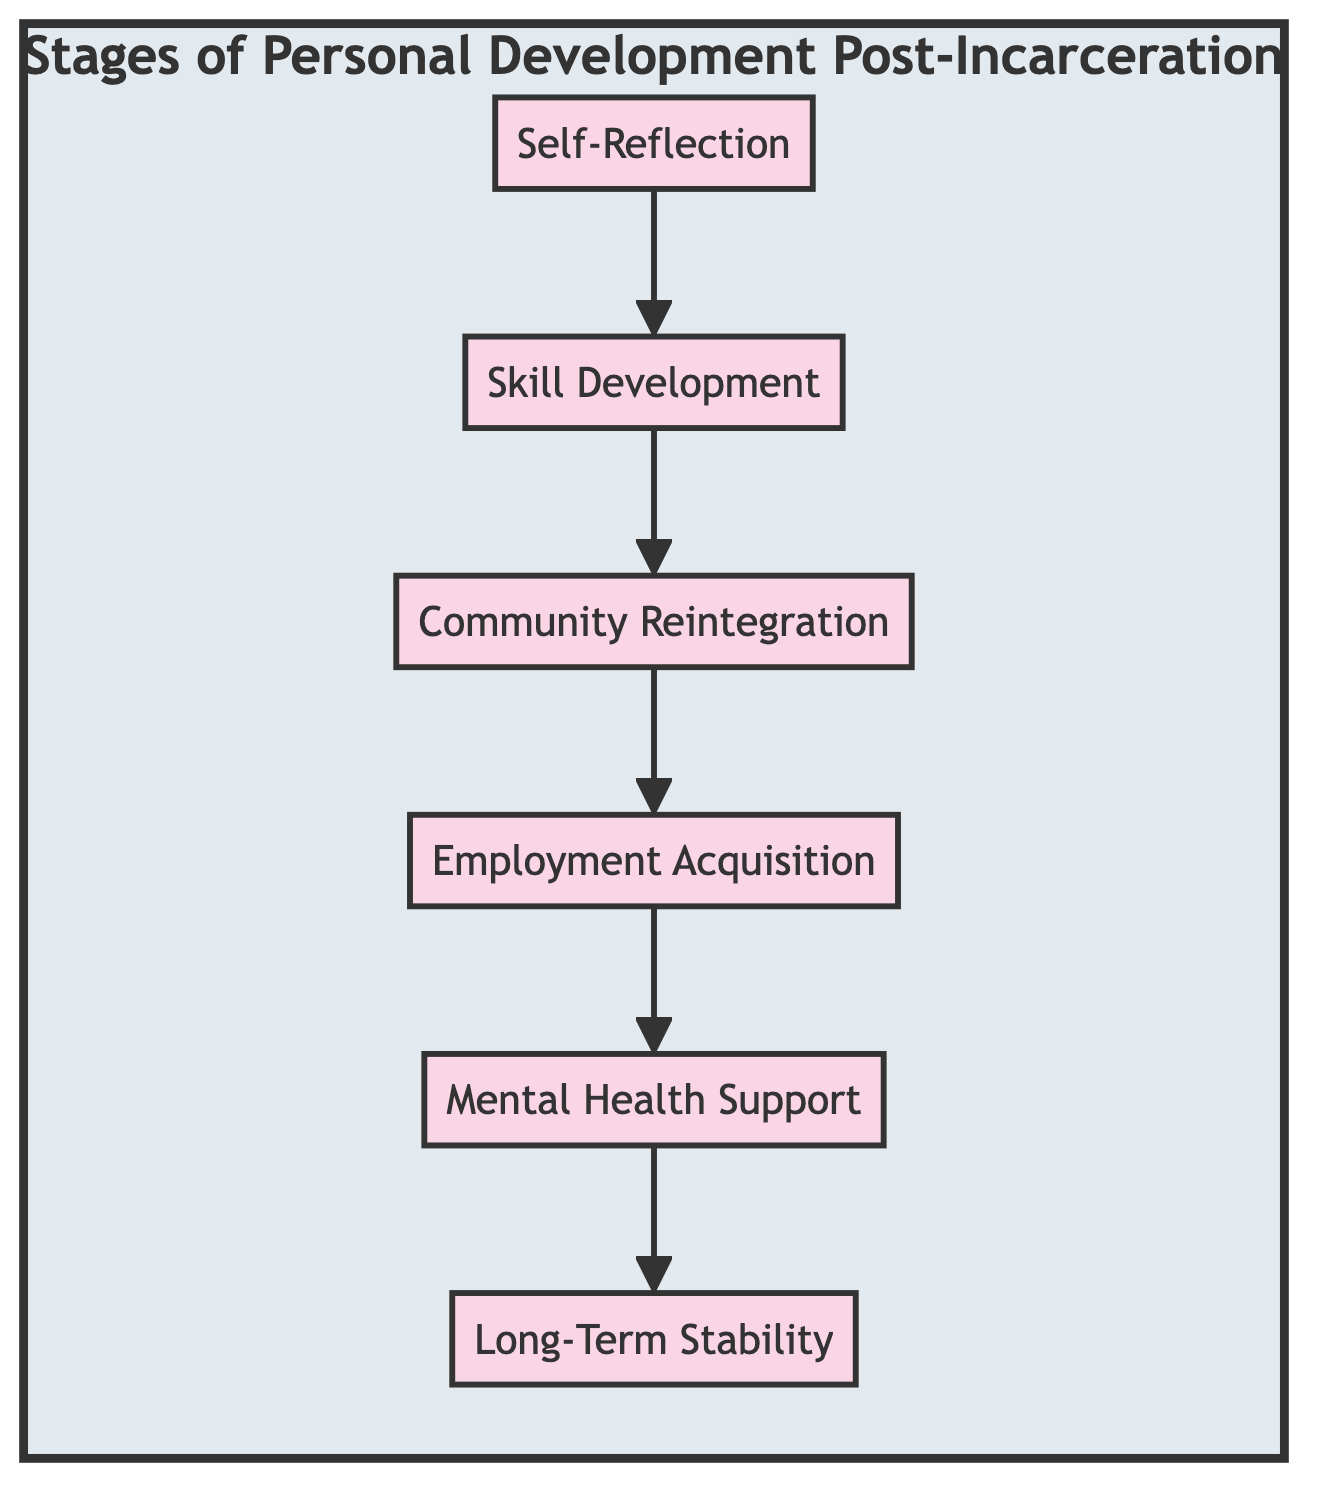What is the first stage of personal development post-incarceration? The diagram indicates that the first stage is labeled "Self-Reflection," shown at the top of the flowchart.
Answer: Self-Reflection How many stages are included in the diagram? By counting the nodes in the diagram, six distinct stages are identified from Self-Reflection to Long-Term Stability.
Answer: 6 What stage directly follows "Skill Development"? The flowchart shows that "Community Reintegration" is the stage connected directly after "Skill Development," indicating its sequence in the process.
Answer: Community Reintegration In which stage is mental health addressed? The diagram links "Mental Health Support" after "Employment Acquisition," indicating this stage focuses on mental health services.
Answer: Mental Health Support Which stage is last in the flow of development? The flowchart concludes with "Long-Term Stability," marking it as the final stage in the process of personal development post-incarceration.
Answer: Long-Term Stability What is the relationship between "Self-Reflection" and "Skill Development"? "Skill Development" follows directly after "Self-Reflection," indicating a sequential process where one stage influences the next.
Answer: Self-Reflection leads to Skill Development How many stages involve community interactions? The stages involving community interactions are "Community Reintegration," which focuses on reconnecting with others, and "Long-Term Stability," which involves nurturing personal relationships, leading to a total of two stages.
Answer: 2 What is the primary purpose of the "Employment Acquisition" stage? The diagram states that this stage is crucial for securing stable employment, thus providing financial independence and a sense of purpose in the individual's development post-incarceration.
Answer: Financial independence Which stage comes before the "Long-Term Stability"? The flowchart clearly shows that "Mental Health Support" is the stage that comes immediately before "Long-Term Stability," establishing its importance in supporting subsequent stability.
Answer: Mental Health Support 